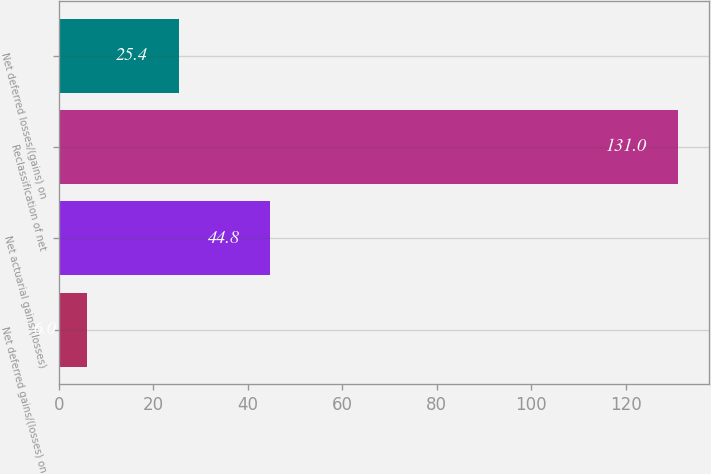<chart> <loc_0><loc_0><loc_500><loc_500><bar_chart><fcel>Net deferred gains/(losses) on<fcel>Net actuarial gains/(losses)<fcel>Reclassification of net<fcel>Net deferred losses/(gains) on<nl><fcel>6<fcel>44.8<fcel>131<fcel>25.4<nl></chart> 